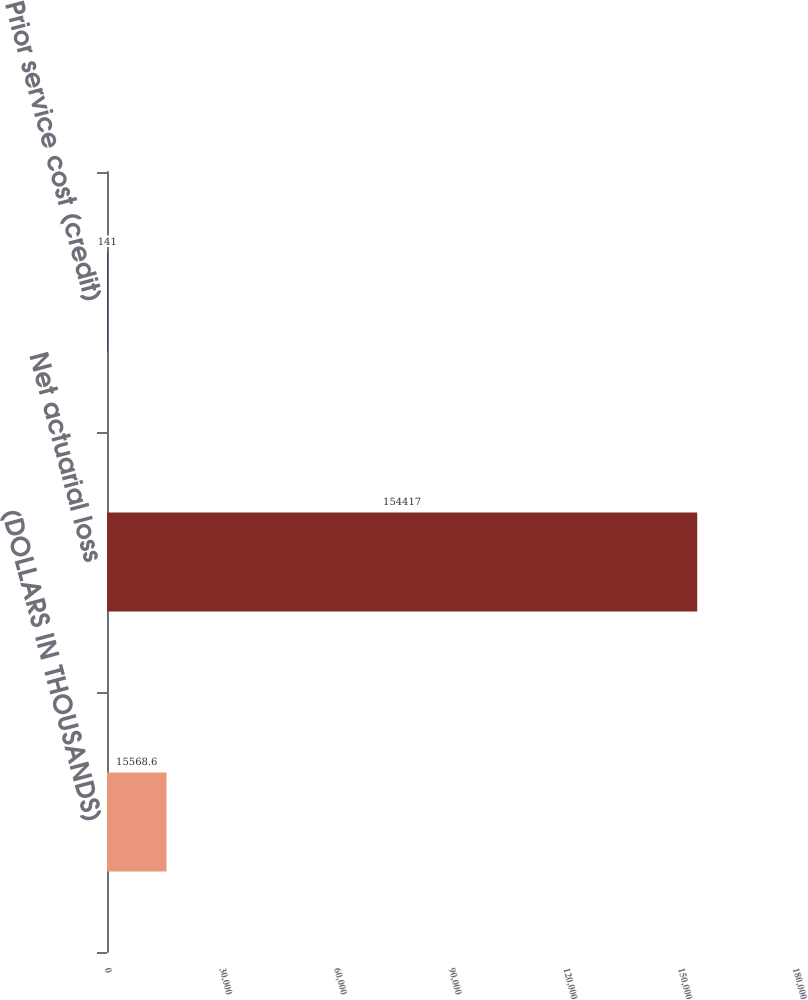<chart> <loc_0><loc_0><loc_500><loc_500><bar_chart><fcel>(DOLLARS IN THOUSANDS)<fcel>Net actuarial loss<fcel>Prior service cost (credit)<nl><fcel>15568.6<fcel>154417<fcel>141<nl></chart> 